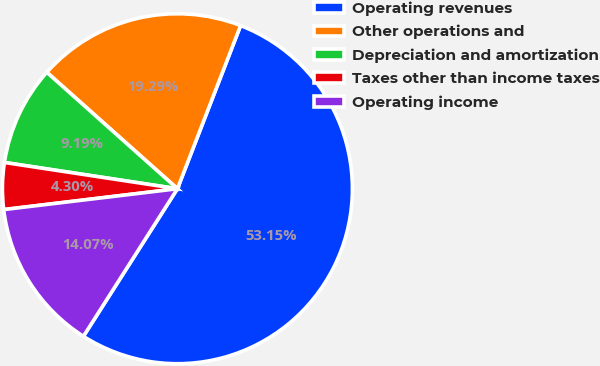Convert chart to OTSL. <chart><loc_0><loc_0><loc_500><loc_500><pie_chart><fcel>Operating revenues<fcel>Other operations and<fcel>Depreciation and amortization<fcel>Taxes other than income taxes<fcel>Operating income<nl><fcel>53.15%<fcel>19.29%<fcel>9.19%<fcel>4.3%<fcel>14.07%<nl></chart> 